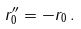<formula> <loc_0><loc_0><loc_500><loc_500>r _ { 0 } ^ { \prime \prime } = - r _ { 0 } \, .</formula> 